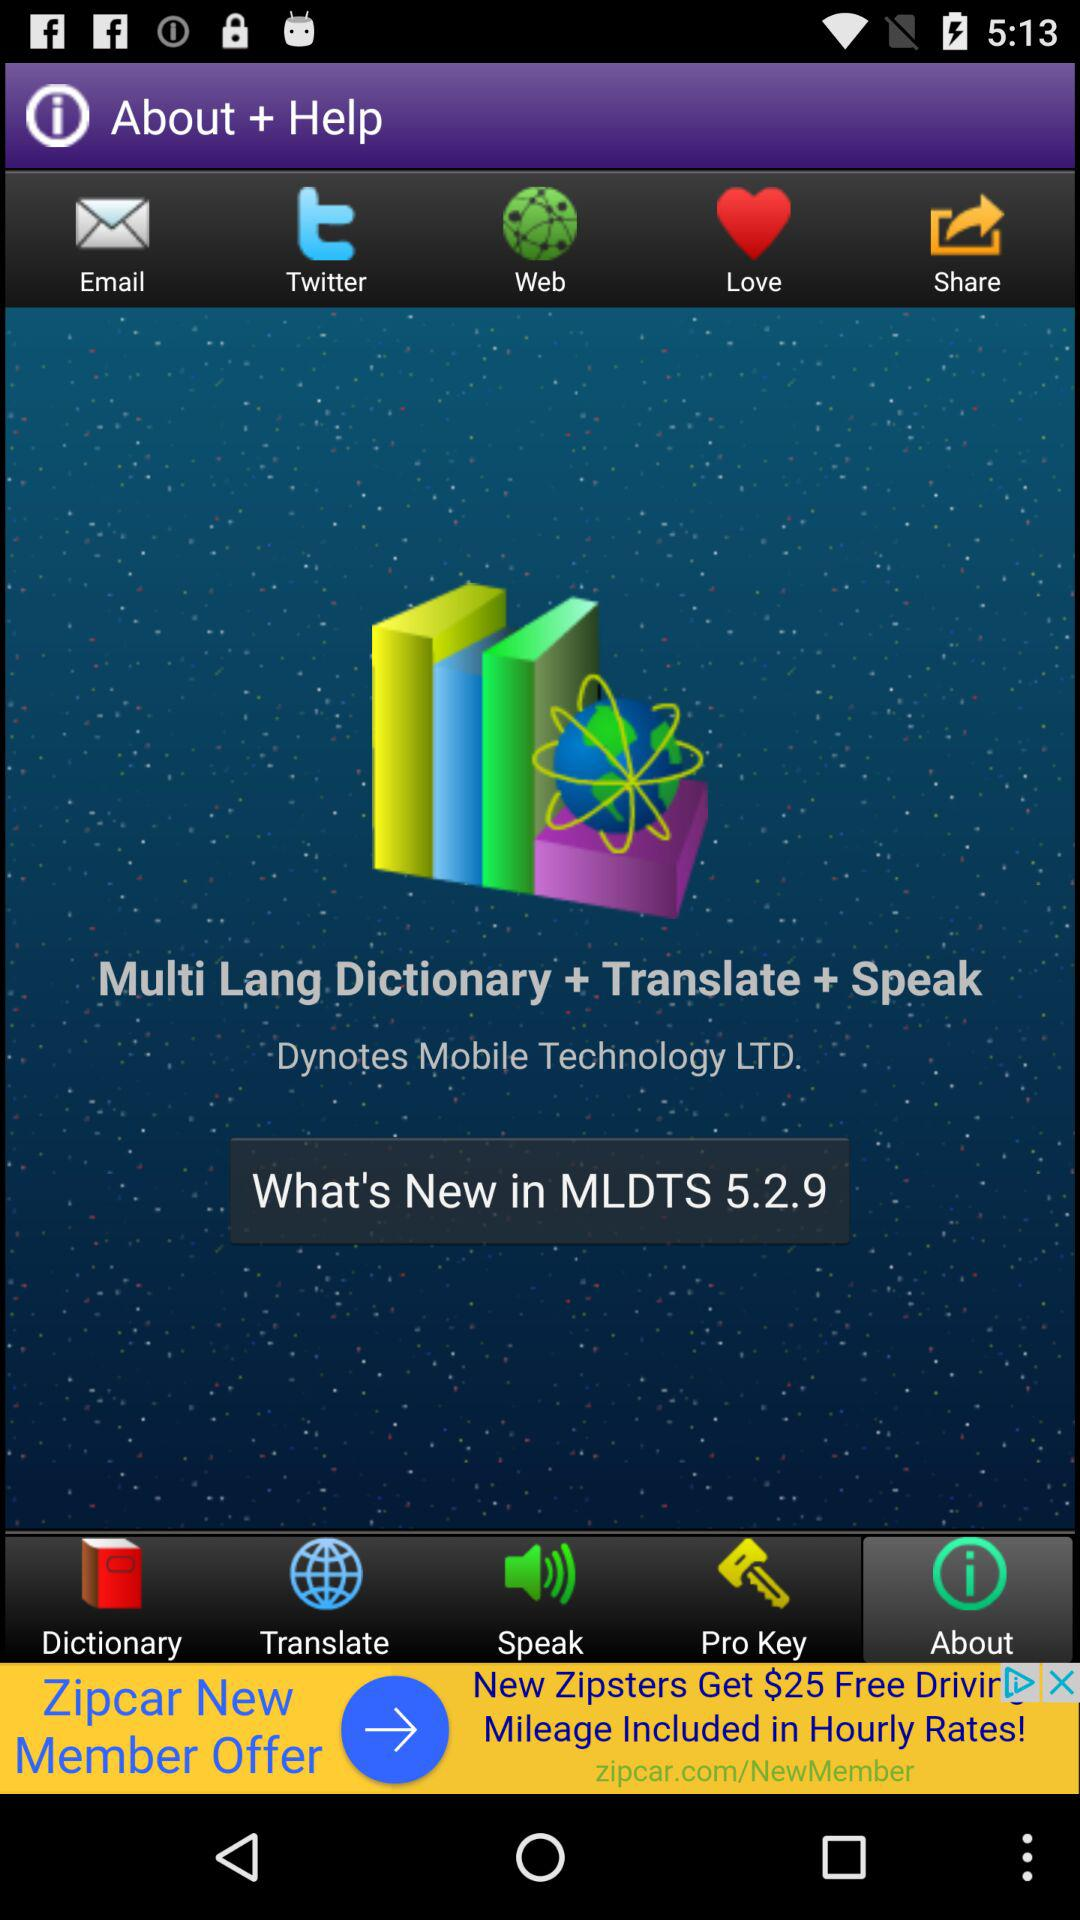What is the full form of MLDTS? The full form of MLDTS is "Multi Lang Dictionary + Translate + Speak". 